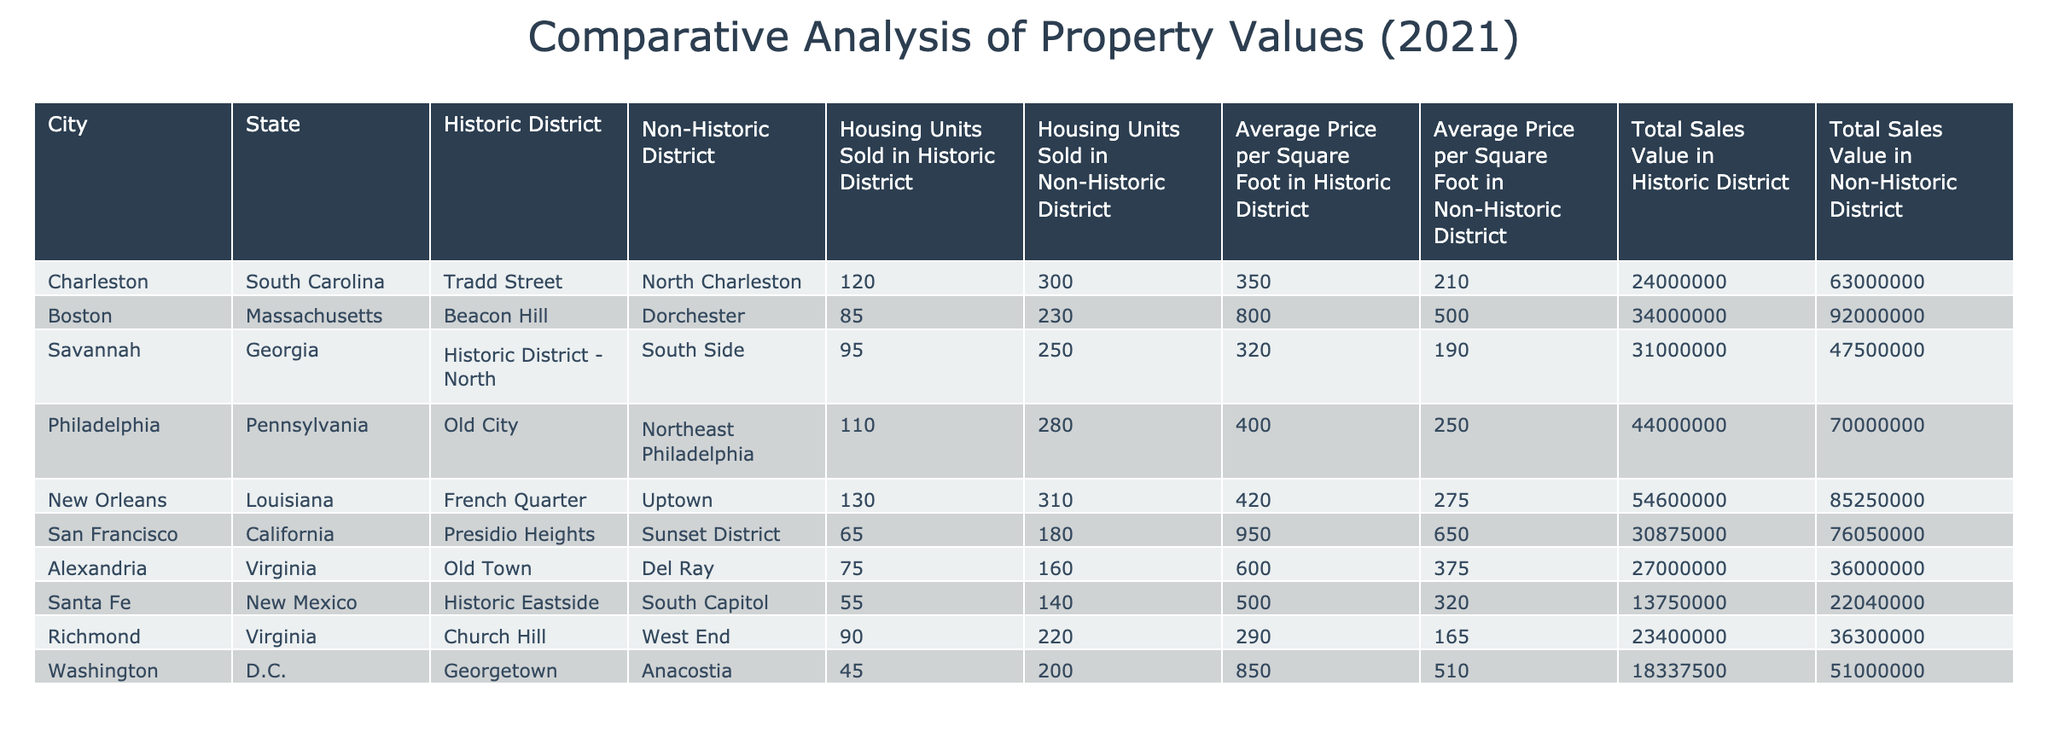What is the average price per square foot in the Historic District of Charleston? The average price per square foot in the Historic District of Charleston is directly provided in the table under the relevant column, which is 350.
Answer: 350 Which city has the highest total sales value in the Non-Historic District? By reviewing the total sales values for the Non-Historic District for each city, the highest value is identified in Boston with a total of 92000000.
Answer: Boston How many more housing units were sold in Non-Historic Districts than in Historic Districts in Philadelphia? In Philadelphia, the number of housing units sold in Historic Districts is 110 and in Non-Historic Districts is 280. The difference is calculated as 280 - 110 = 170.
Answer: 170 Is the average price per square foot in the Non-Historic District of Richmond higher than 200? Checking the average price per square foot in the Non-Historic District of Richmond, which is 165, confirms that it is lower than 200.
Answer: No What is the overall total sales value in Historic Districts for all cities combined in this analysis? To find the overall total sales value in Historic Districts, sum the individual total sales values from each city: 24000000 + 34000000 + 31000000 + 44000000 + 54600000 + 30875000 + 27000000 + 13750000 + 23400000 + 18337500 = 211632500.
Answer: 211632500 Which city has the smallest difference in average price per square foot between Historic and Non-Historic Districts? To find the smallest difference, we compare the differences for each city: Charleston (350-210=140), Boston (800-500=300), Savannah (320-190=130), Philadelphia (400-250=150), New Orleans (420-275=145), etc. The smallest difference is in Savannah, which is 130.
Answer: Savannah Are there more housing units sold in total across all Historic Districts compared to all Non-Historic Districts? The total housing units sold in Historic Districts can be calculated as 120 + 85 + 95 + 110 + 130 + 65 + 75 + 55 + 90 + 45 = 1,000. The total for Non-Historic Districts is 300 + 230 + 250 + 280 + 310 + 180 + 160 + 140 + 220 + 200 = 2,020. Since 1,000 < 2,020, there are fewer units sold in Historic Districts.
Answer: No What is the average price per square foot in Historic Districts across all listed cities? Calculate the average price by summing the average prices per square foot in Historic Districts: (350 + 800 + 320 + 400 + 420 + 950 + 600 + 500 + 290 + 850) / 10 = 543.
Answer: 543 Which city had the highest number of housing units sold in its Historic District? The table shows that New Orleans had the highest number of housing units sold in its Historic District with a total of 130.
Answer: New Orleans 